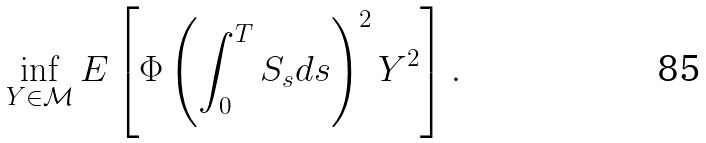Convert formula to latex. <formula><loc_0><loc_0><loc_500><loc_500>\inf _ { Y \in \mathcal { M } } E \left [ \Phi \left ( \int _ { 0 } ^ { T } S _ { s } d s \right ) ^ { 2 } Y ^ { 2 } \right ] .</formula> 